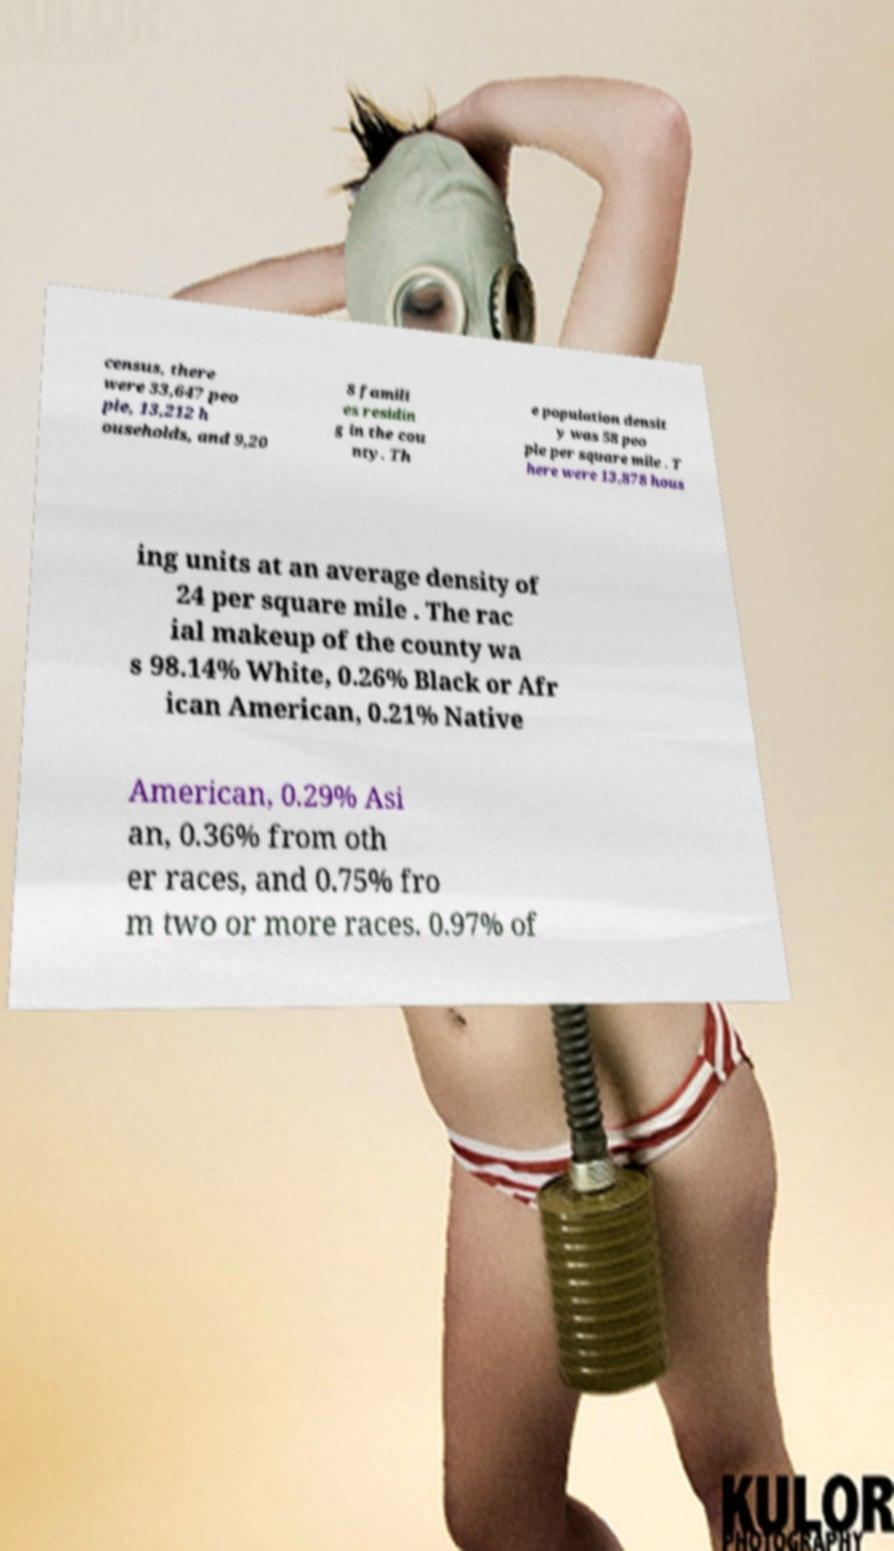There's text embedded in this image that I need extracted. Can you transcribe it verbatim? census, there were 33,647 peo ple, 13,212 h ouseholds, and 9,20 8 famili es residin g in the cou nty. Th e population densit y was 58 peo ple per square mile . T here were 13,878 hous ing units at an average density of 24 per square mile . The rac ial makeup of the county wa s 98.14% White, 0.26% Black or Afr ican American, 0.21% Native American, 0.29% Asi an, 0.36% from oth er races, and 0.75% fro m two or more races. 0.97% of 